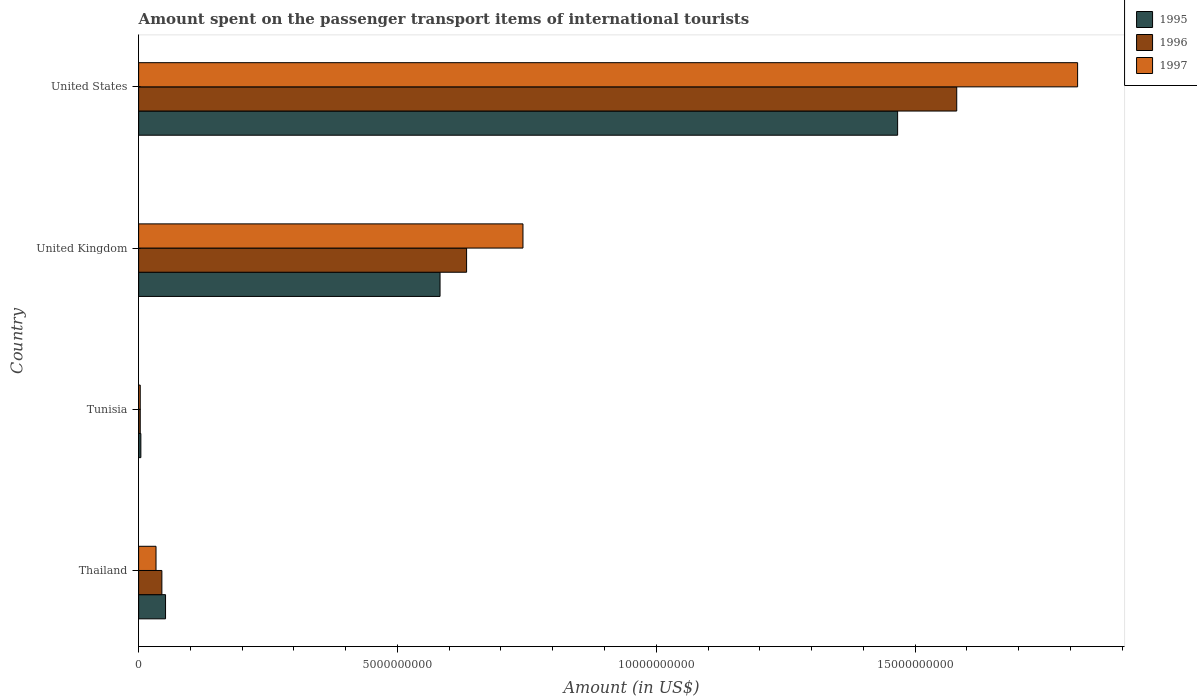How many groups of bars are there?
Make the answer very short. 4. Are the number of bars per tick equal to the number of legend labels?
Offer a terse response. Yes. What is the label of the 1st group of bars from the top?
Ensure brevity in your answer.  United States. What is the amount spent on the passenger transport items of international tourists in 1997 in United Kingdom?
Provide a succinct answer. 7.42e+09. Across all countries, what is the maximum amount spent on the passenger transport items of international tourists in 1995?
Provide a succinct answer. 1.47e+1. Across all countries, what is the minimum amount spent on the passenger transport items of international tourists in 1996?
Your answer should be very brief. 3.10e+07. In which country was the amount spent on the passenger transport items of international tourists in 1997 minimum?
Your answer should be very brief. Tunisia. What is the total amount spent on the passenger transport items of international tourists in 1995 in the graph?
Your answer should be compact. 2.10e+1. What is the difference between the amount spent on the passenger transport items of international tourists in 1996 in Thailand and that in Tunisia?
Make the answer very short. 4.18e+08. What is the difference between the amount spent on the passenger transport items of international tourists in 1995 in United Kingdom and the amount spent on the passenger transport items of international tourists in 1997 in Thailand?
Your answer should be compact. 5.49e+09. What is the average amount spent on the passenger transport items of international tourists in 1995 per country?
Keep it short and to the point. 5.26e+09. What is the difference between the amount spent on the passenger transport items of international tourists in 1995 and amount spent on the passenger transport items of international tourists in 1997 in Tunisia?
Offer a very short reply. 1.20e+07. What is the ratio of the amount spent on the passenger transport items of international tourists in 1997 in Thailand to that in United Kingdom?
Your answer should be very brief. 0.05. Is the amount spent on the passenger transport items of international tourists in 1996 in Tunisia less than that in United Kingdom?
Provide a short and direct response. Yes. Is the difference between the amount spent on the passenger transport items of international tourists in 1995 in United Kingdom and United States greater than the difference between the amount spent on the passenger transport items of international tourists in 1997 in United Kingdom and United States?
Provide a succinct answer. Yes. What is the difference between the highest and the second highest amount spent on the passenger transport items of international tourists in 1996?
Give a very brief answer. 9.47e+09. What is the difference between the highest and the lowest amount spent on the passenger transport items of international tourists in 1997?
Provide a succinct answer. 1.81e+1. In how many countries, is the amount spent on the passenger transport items of international tourists in 1997 greater than the average amount spent on the passenger transport items of international tourists in 1997 taken over all countries?
Provide a short and direct response. 2. What does the 2nd bar from the top in Tunisia represents?
Provide a short and direct response. 1996. Is it the case that in every country, the sum of the amount spent on the passenger transport items of international tourists in 1996 and amount spent on the passenger transport items of international tourists in 1995 is greater than the amount spent on the passenger transport items of international tourists in 1997?
Provide a short and direct response. Yes. Are the values on the major ticks of X-axis written in scientific E-notation?
Offer a very short reply. No. Does the graph contain any zero values?
Offer a very short reply. No. Does the graph contain grids?
Give a very brief answer. No. How many legend labels are there?
Offer a terse response. 3. How are the legend labels stacked?
Your answer should be very brief. Vertical. What is the title of the graph?
Provide a succinct answer. Amount spent on the passenger transport items of international tourists. Does "1978" appear as one of the legend labels in the graph?
Make the answer very short. No. What is the label or title of the X-axis?
Keep it short and to the point. Amount (in US$). What is the Amount (in US$) of 1995 in Thailand?
Keep it short and to the point. 5.20e+08. What is the Amount (in US$) of 1996 in Thailand?
Provide a succinct answer. 4.49e+08. What is the Amount (in US$) of 1997 in Thailand?
Your answer should be very brief. 3.36e+08. What is the Amount (in US$) of 1995 in Tunisia?
Provide a short and direct response. 4.30e+07. What is the Amount (in US$) of 1996 in Tunisia?
Your response must be concise. 3.10e+07. What is the Amount (in US$) of 1997 in Tunisia?
Provide a succinct answer. 3.10e+07. What is the Amount (in US$) of 1995 in United Kingdom?
Offer a terse response. 5.82e+09. What is the Amount (in US$) of 1996 in United Kingdom?
Offer a very short reply. 6.34e+09. What is the Amount (in US$) in 1997 in United Kingdom?
Offer a very short reply. 7.42e+09. What is the Amount (in US$) of 1995 in United States?
Your answer should be compact. 1.47e+1. What is the Amount (in US$) of 1996 in United States?
Give a very brief answer. 1.58e+1. What is the Amount (in US$) in 1997 in United States?
Ensure brevity in your answer.  1.81e+1. Across all countries, what is the maximum Amount (in US$) of 1995?
Provide a succinct answer. 1.47e+1. Across all countries, what is the maximum Amount (in US$) in 1996?
Provide a short and direct response. 1.58e+1. Across all countries, what is the maximum Amount (in US$) in 1997?
Provide a short and direct response. 1.81e+1. Across all countries, what is the minimum Amount (in US$) of 1995?
Your answer should be compact. 4.30e+07. Across all countries, what is the minimum Amount (in US$) in 1996?
Give a very brief answer. 3.10e+07. Across all countries, what is the minimum Amount (in US$) of 1997?
Offer a very short reply. 3.10e+07. What is the total Amount (in US$) of 1995 in the graph?
Make the answer very short. 2.10e+1. What is the total Amount (in US$) of 1996 in the graph?
Your response must be concise. 2.26e+1. What is the total Amount (in US$) of 1997 in the graph?
Your answer should be very brief. 2.59e+1. What is the difference between the Amount (in US$) of 1995 in Thailand and that in Tunisia?
Keep it short and to the point. 4.77e+08. What is the difference between the Amount (in US$) of 1996 in Thailand and that in Tunisia?
Your response must be concise. 4.18e+08. What is the difference between the Amount (in US$) in 1997 in Thailand and that in Tunisia?
Your response must be concise. 3.05e+08. What is the difference between the Amount (in US$) in 1995 in Thailand and that in United Kingdom?
Your response must be concise. -5.30e+09. What is the difference between the Amount (in US$) of 1996 in Thailand and that in United Kingdom?
Your response must be concise. -5.89e+09. What is the difference between the Amount (in US$) in 1997 in Thailand and that in United Kingdom?
Your answer should be very brief. -7.09e+09. What is the difference between the Amount (in US$) of 1995 in Thailand and that in United States?
Offer a very short reply. -1.41e+1. What is the difference between the Amount (in US$) in 1996 in Thailand and that in United States?
Provide a short and direct response. -1.54e+1. What is the difference between the Amount (in US$) of 1997 in Thailand and that in United States?
Keep it short and to the point. -1.78e+1. What is the difference between the Amount (in US$) in 1995 in Tunisia and that in United Kingdom?
Offer a very short reply. -5.78e+09. What is the difference between the Amount (in US$) in 1996 in Tunisia and that in United Kingdom?
Make the answer very short. -6.30e+09. What is the difference between the Amount (in US$) of 1997 in Tunisia and that in United Kingdom?
Provide a succinct answer. -7.39e+09. What is the difference between the Amount (in US$) of 1995 in Tunisia and that in United States?
Make the answer very short. -1.46e+1. What is the difference between the Amount (in US$) in 1996 in Tunisia and that in United States?
Keep it short and to the point. -1.58e+1. What is the difference between the Amount (in US$) of 1997 in Tunisia and that in United States?
Offer a very short reply. -1.81e+1. What is the difference between the Amount (in US$) in 1995 in United Kingdom and that in United States?
Offer a terse response. -8.84e+09. What is the difference between the Amount (in US$) of 1996 in United Kingdom and that in United States?
Your answer should be compact. -9.47e+09. What is the difference between the Amount (in US$) of 1997 in United Kingdom and that in United States?
Your answer should be compact. -1.07e+1. What is the difference between the Amount (in US$) of 1995 in Thailand and the Amount (in US$) of 1996 in Tunisia?
Your response must be concise. 4.89e+08. What is the difference between the Amount (in US$) of 1995 in Thailand and the Amount (in US$) of 1997 in Tunisia?
Make the answer very short. 4.89e+08. What is the difference between the Amount (in US$) of 1996 in Thailand and the Amount (in US$) of 1997 in Tunisia?
Offer a very short reply. 4.18e+08. What is the difference between the Amount (in US$) in 1995 in Thailand and the Amount (in US$) in 1996 in United Kingdom?
Your response must be concise. -5.82e+09. What is the difference between the Amount (in US$) in 1995 in Thailand and the Amount (in US$) in 1997 in United Kingdom?
Make the answer very short. -6.90e+09. What is the difference between the Amount (in US$) of 1996 in Thailand and the Amount (in US$) of 1997 in United Kingdom?
Provide a succinct answer. -6.98e+09. What is the difference between the Amount (in US$) of 1995 in Thailand and the Amount (in US$) of 1996 in United States?
Your answer should be compact. -1.53e+1. What is the difference between the Amount (in US$) of 1995 in Thailand and the Amount (in US$) of 1997 in United States?
Offer a very short reply. -1.76e+1. What is the difference between the Amount (in US$) in 1996 in Thailand and the Amount (in US$) in 1997 in United States?
Offer a terse response. -1.77e+1. What is the difference between the Amount (in US$) of 1995 in Tunisia and the Amount (in US$) of 1996 in United Kingdom?
Your answer should be compact. -6.29e+09. What is the difference between the Amount (in US$) of 1995 in Tunisia and the Amount (in US$) of 1997 in United Kingdom?
Keep it short and to the point. -7.38e+09. What is the difference between the Amount (in US$) of 1996 in Tunisia and the Amount (in US$) of 1997 in United Kingdom?
Your answer should be very brief. -7.39e+09. What is the difference between the Amount (in US$) of 1995 in Tunisia and the Amount (in US$) of 1996 in United States?
Give a very brief answer. -1.58e+1. What is the difference between the Amount (in US$) of 1995 in Tunisia and the Amount (in US$) of 1997 in United States?
Keep it short and to the point. -1.81e+1. What is the difference between the Amount (in US$) in 1996 in Tunisia and the Amount (in US$) in 1997 in United States?
Offer a terse response. -1.81e+1. What is the difference between the Amount (in US$) in 1995 in United Kingdom and the Amount (in US$) in 1996 in United States?
Provide a short and direct response. -9.98e+09. What is the difference between the Amount (in US$) of 1995 in United Kingdom and the Amount (in US$) of 1997 in United States?
Give a very brief answer. -1.23e+1. What is the difference between the Amount (in US$) in 1996 in United Kingdom and the Amount (in US$) in 1997 in United States?
Provide a succinct answer. -1.18e+1. What is the average Amount (in US$) of 1995 per country?
Provide a short and direct response. 5.26e+09. What is the average Amount (in US$) of 1996 per country?
Give a very brief answer. 5.66e+09. What is the average Amount (in US$) of 1997 per country?
Keep it short and to the point. 6.48e+09. What is the difference between the Amount (in US$) of 1995 and Amount (in US$) of 1996 in Thailand?
Provide a succinct answer. 7.10e+07. What is the difference between the Amount (in US$) in 1995 and Amount (in US$) in 1997 in Thailand?
Provide a succinct answer. 1.84e+08. What is the difference between the Amount (in US$) of 1996 and Amount (in US$) of 1997 in Thailand?
Make the answer very short. 1.13e+08. What is the difference between the Amount (in US$) in 1995 and Amount (in US$) in 1996 in Tunisia?
Keep it short and to the point. 1.20e+07. What is the difference between the Amount (in US$) of 1995 and Amount (in US$) of 1996 in United Kingdom?
Offer a terse response. -5.13e+08. What is the difference between the Amount (in US$) of 1995 and Amount (in US$) of 1997 in United Kingdom?
Offer a terse response. -1.60e+09. What is the difference between the Amount (in US$) in 1996 and Amount (in US$) in 1997 in United Kingdom?
Offer a very short reply. -1.09e+09. What is the difference between the Amount (in US$) in 1995 and Amount (in US$) in 1996 in United States?
Offer a very short reply. -1.14e+09. What is the difference between the Amount (in US$) of 1995 and Amount (in US$) of 1997 in United States?
Your answer should be compact. -3.48e+09. What is the difference between the Amount (in US$) in 1996 and Amount (in US$) in 1997 in United States?
Offer a terse response. -2.34e+09. What is the ratio of the Amount (in US$) in 1995 in Thailand to that in Tunisia?
Give a very brief answer. 12.09. What is the ratio of the Amount (in US$) in 1996 in Thailand to that in Tunisia?
Keep it short and to the point. 14.48. What is the ratio of the Amount (in US$) of 1997 in Thailand to that in Tunisia?
Offer a very short reply. 10.84. What is the ratio of the Amount (in US$) of 1995 in Thailand to that in United Kingdom?
Your answer should be very brief. 0.09. What is the ratio of the Amount (in US$) in 1996 in Thailand to that in United Kingdom?
Your answer should be very brief. 0.07. What is the ratio of the Amount (in US$) of 1997 in Thailand to that in United Kingdom?
Your answer should be compact. 0.05. What is the ratio of the Amount (in US$) in 1995 in Thailand to that in United States?
Give a very brief answer. 0.04. What is the ratio of the Amount (in US$) in 1996 in Thailand to that in United States?
Provide a short and direct response. 0.03. What is the ratio of the Amount (in US$) in 1997 in Thailand to that in United States?
Provide a succinct answer. 0.02. What is the ratio of the Amount (in US$) of 1995 in Tunisia to that in United Kingdom?
Give a very brief answer. 0.01. What is the ratio of the Amount (in US$) in 1996 in Tunisia to that in United Kingdom?
Your response must be concise. 0. What is the ratio of the Amount (in US$) in 1997 in Tunisia to that in United Kingdom?
Provide a short and direct response. 0. What is the ratio of the Amount (in US$) in 1995 in Tunisia to that in United States?
Make the answer very short. 0. What is the ratio of the Amount (in US$) in 1996 in Tunisia to that in United States?
Your answer should be very brief. 0. What is the ratio of the Amount (in US$) of 1997 in Tunisia to that in United States?
Offer a terse response. 0. What is the ratio of the Amount (in US$) of 1995 in United Kingdom to that in United States?
Your response must be concise. 0.4. What is the ratio of the Amount (in US$) of 1996 in United Kingdom to that in United States?
Provide a succinct answer. 0.4. What is the ratio of the Amount (in US$) in 1997 in United Kingdom to that in United States?
Ensure brevity in your answer.  0.41. What is the difference between the highest and the second highest Amount (in US$) in 1995?
Offer a terse response. 8.84e+09. What is the difference between the highest and the second highest Amount (in US$) in 1996?
Provide a succinct answer. 9.47e+09. What is the difference between the highest and the second highest Amount (in US$) of 1997?
Provide a short and direct response. 1.07e+1. What is the difference between the highest and the lowest Amount (in US$) of 1995?
Your answer should be compact. 1.46e+1. What is the difference between the highest and the lowest Amount (in US$) of 1996?
Offer a terse response. 1.58e+1. What is the difference between the highest and the lowest Amount (in US$) in 1997?
Keep it short and to the point. 1.81e+1. 